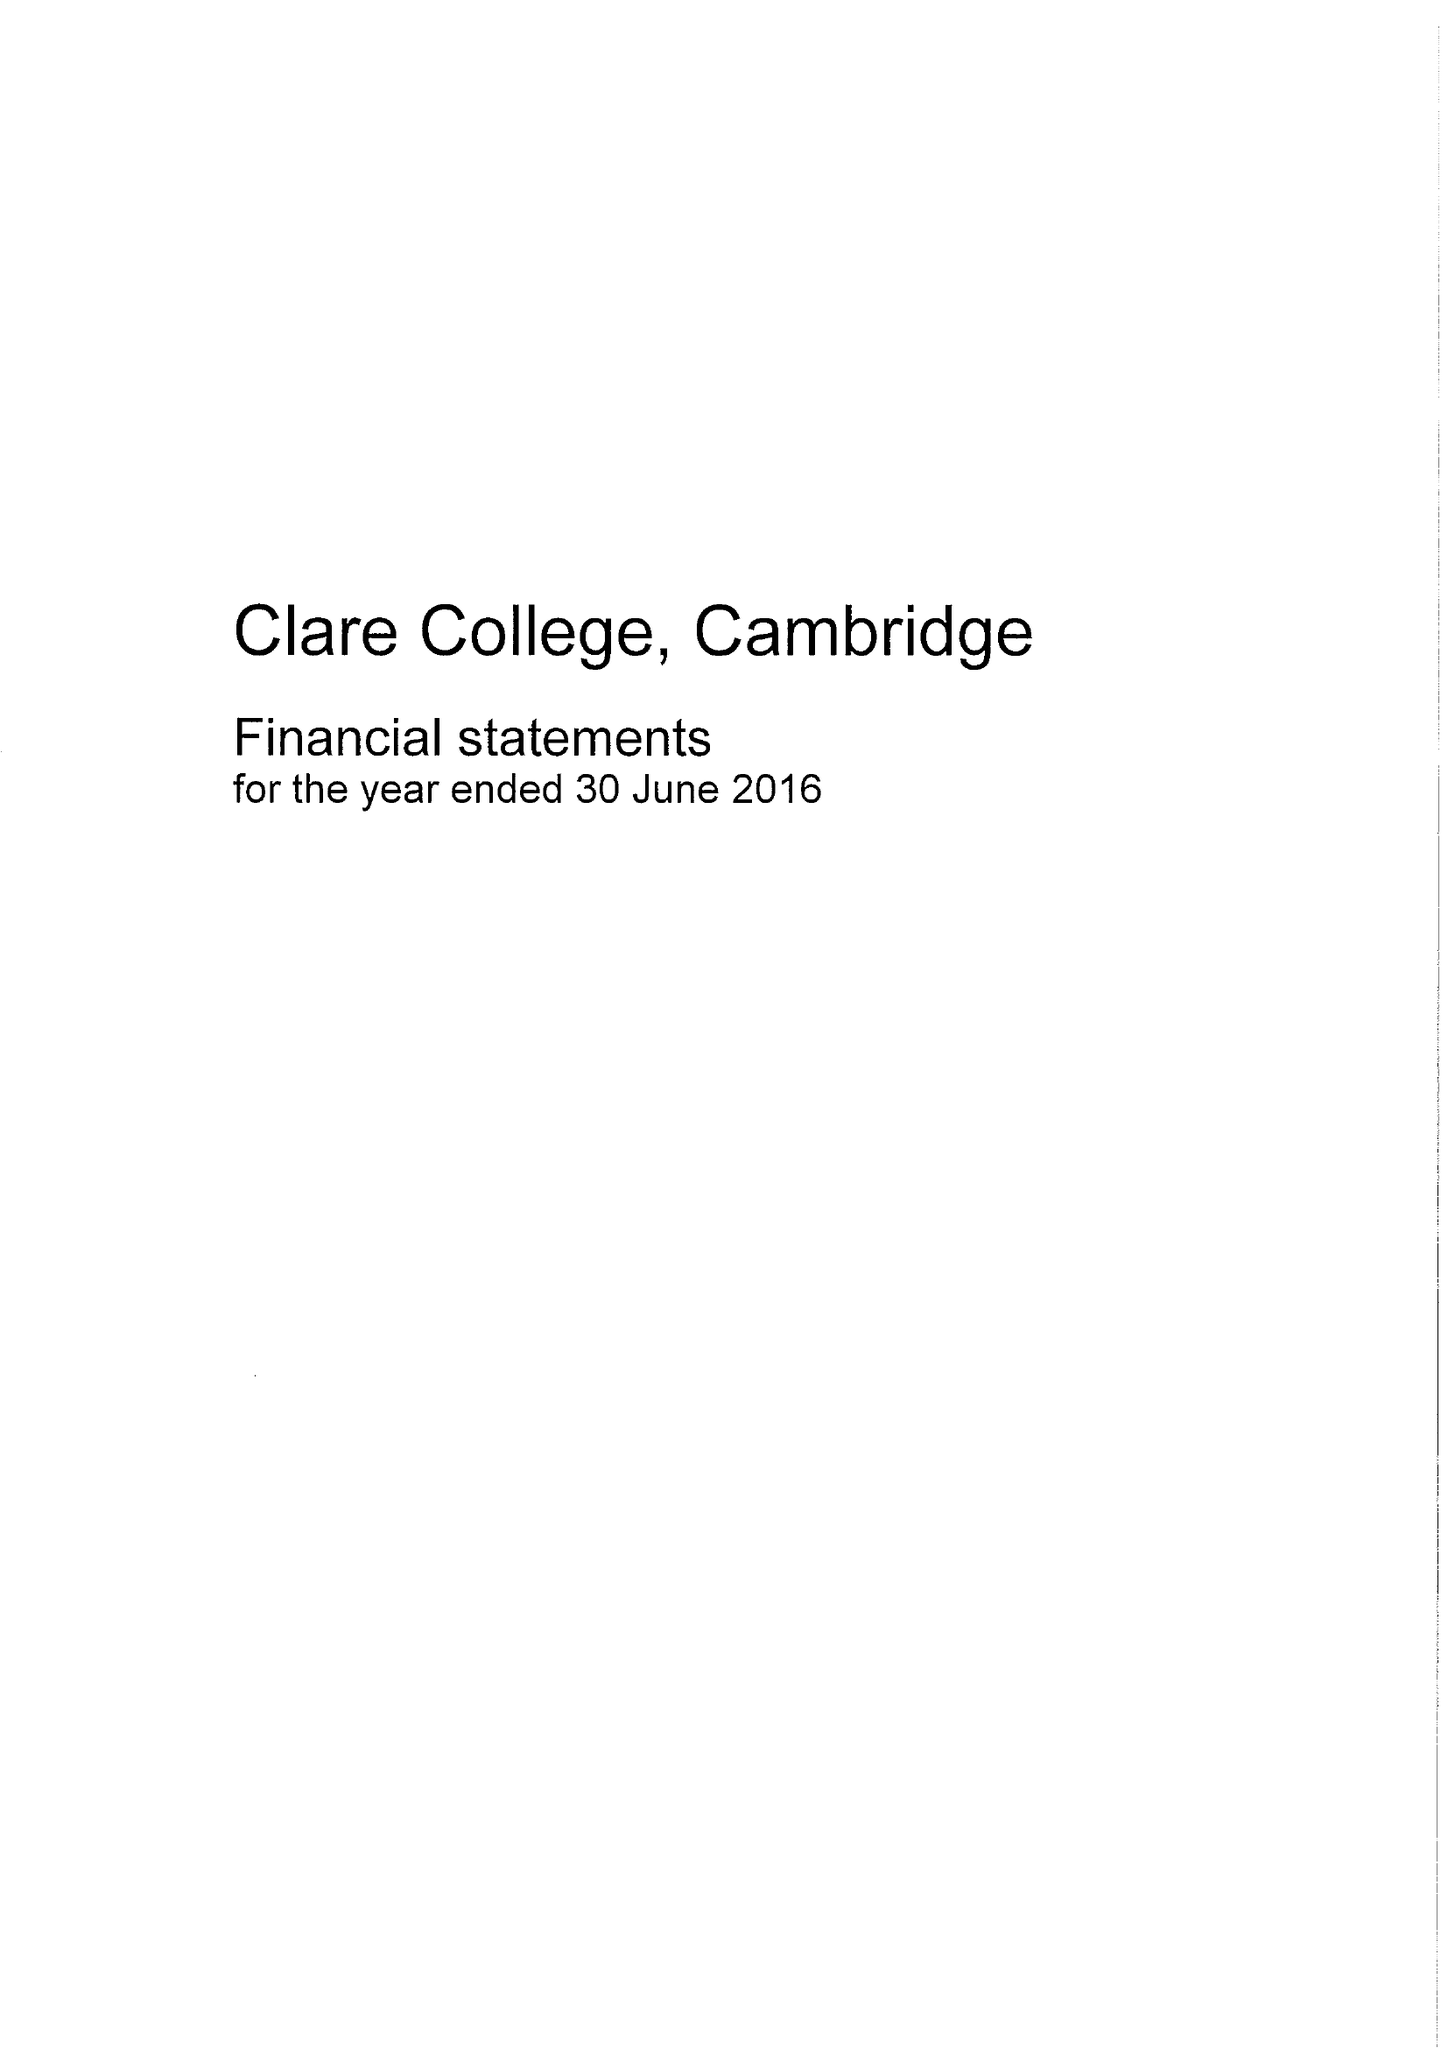What is the value for the address__post_town?
Answer the question using a single word or phrase. CAMBRIDGE 